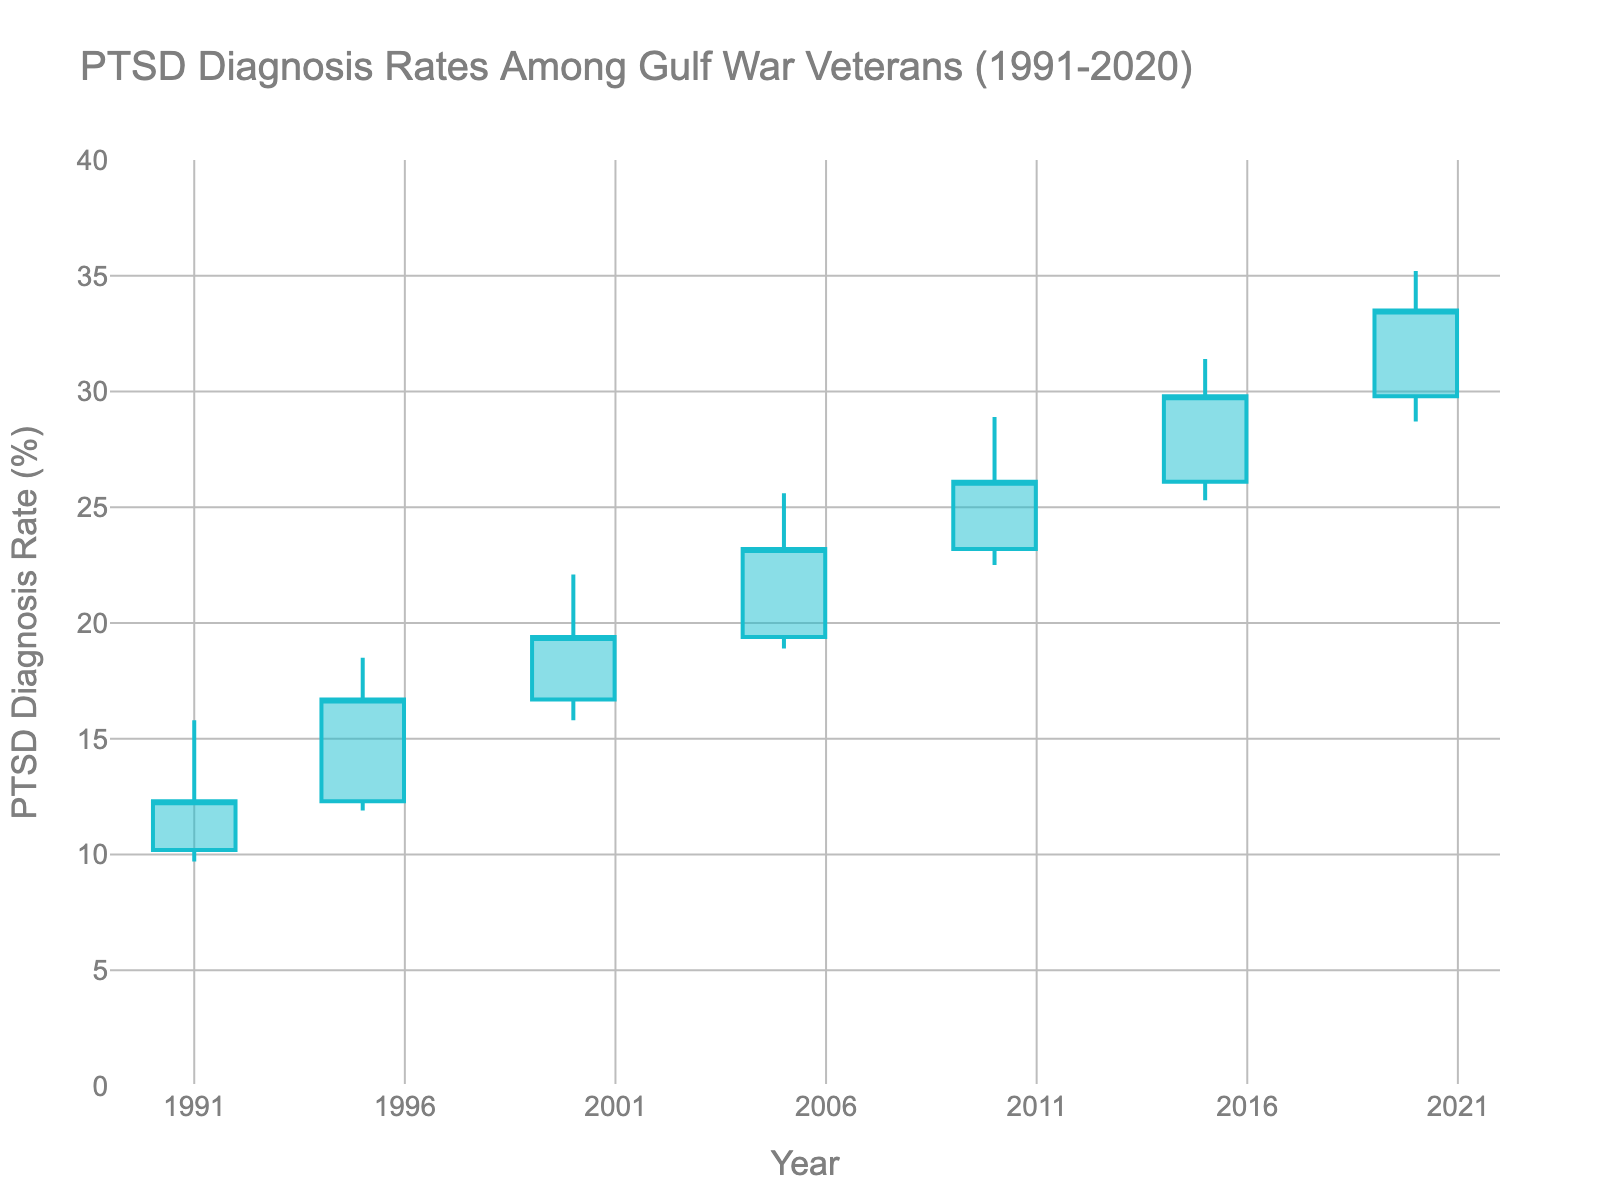What's the title of the figure? The title is displayed at the top of the figure and immediately gives an overview of the data being represented. It reads "PTSD Diagnosis Rates Among Gulf War Veterans (1991-2020)."
Answer: PTSD Diagnosis Rates Among Gulf War Veterans (1991-2020) How many years are covered in this chart? The x-axis of the chart shows data points from 1991 to 2020, which are spaced evenly and represent specific years with data points. Counting these, there are 7 data points (1991, 1995, 2000, 2005, 2010, 2015, 2020).
Answer: 7 years What was the lowest rate of PTSD diagnosis recorded in any year? The lowest rate (the minimum) of PTSD diagnosis is shown by the 'Low' values along the bars for the years. The lowest rate among these values is 9.7% in 1991.
Answer: 9.7% Which year had the highest increase in the PTSD diagnosis rate between the start and end of the year? To find the year with the highest increase, we need to compare the difference between the 'Open' and 'Close' values across all years. The year 1995 shows the biggest increase, from 12.3% to 16.7%, which is an increase of 4.4%.
Answer: 1995 What was the PTSD diagnosis rate at the close of 2020? The 'Close' value for the year 2020 indicates the PTSD diagnosis rate at the end of that year, which is 33.5%.
Answer: 33.5% Between which two consecutive years was the increase in the closing rate the highest? We need to find differences between consecutive 'Close' values. The biggest increase, 3.7%, occurs between 2015 (29.8%) and 2020 (33.5%).
Answer: Between 2015 and 2020 What is the average of the highest recorded PTSD diagnosis rates across the years? The 'High' values need to be added and averaged: (15.8 + 18.5 + 22.1 + 25.6 + 28.9 + 31.4 + 35.2) / 7 = 176.5 / 7 = 25.2
Answer: 25.2% Which year had the smallest range in PTSD diagnosis rates? The range is given by the difference between 'High' and 'Low' values. 2010 has the smallest range: 28.9% - 22.5% = 6.4%.
Answer: 2010 In which year did the PTSD diagnosis rate surpass 20% for the first time? Checking the first occurrence where the 'Close' value exceeds 20%, it is in the year 2000 when the rate closed at 19.4%, but surpassed 20% next at 2005.
Answer: 2005 